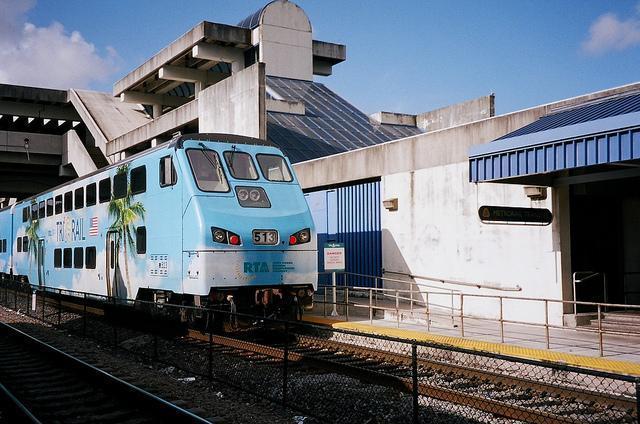How many blue trains are there?
Give a very brief answer. 1. How many little boys are wearing a purple shirt?
Give a very brief answer. 0. 